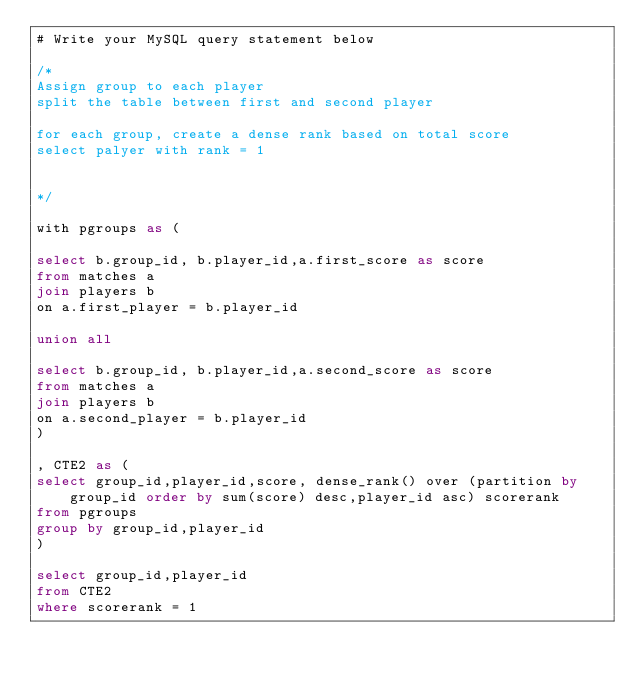<code> <loc_0><loc_0><loc_500><loc_500><_SQL_># Write your MySQL query statement below

/*
Assign group to each player
split the table between first and second player

for each group, create a dense rank based on total score
select palyer with rank = 1


*/

with pgroups as (

select b.group_id, b.player_id,a.first_score as score
from matches a
join players b
on a.first_player = b.player_id

union all

select b.group_id, b.player_id,a.second_score as score
from matches a
join players b
on a.second_player = b.player_id
)

, CTE2 as (
select group_id,player_id,score, dense_rank() over (partition by group_id order by sum(score) desc,player_id asc) scorerank
from pgroups
group by group_id,player_id
)

select group_id,player_id
from CTE2
where scorerank = 1


</code> 